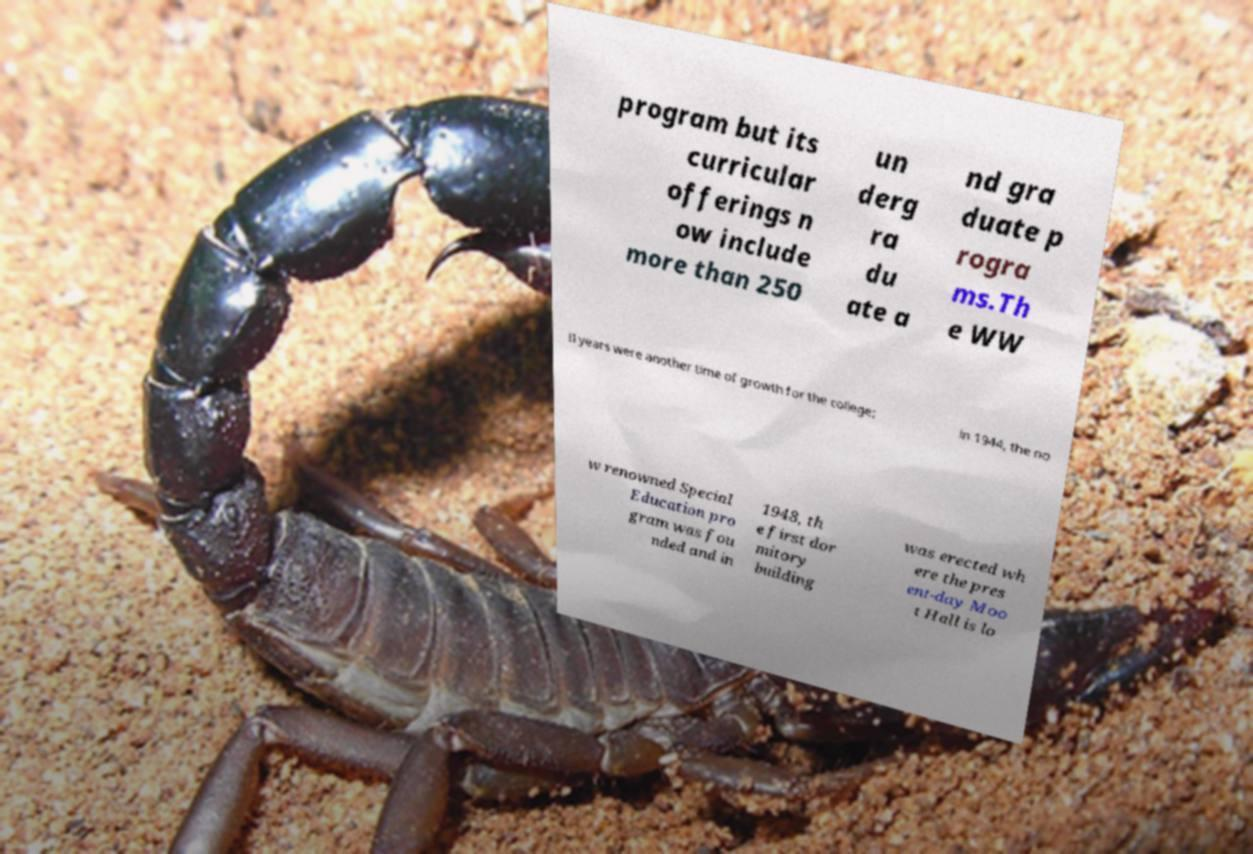Can you accurately transcribe the text from the provided image for me? program but its curricular offerings n ow include more than 250 un derg ra du ate a nd gra duate p rogra ms.Th e WW II years were another time of growth for the college; in 1944, the no w renowned Special Education pro gram was fou nded and in 1948, th e first dor mitory building was erected wh ere the pres ent-day Moo t Hall is lo 